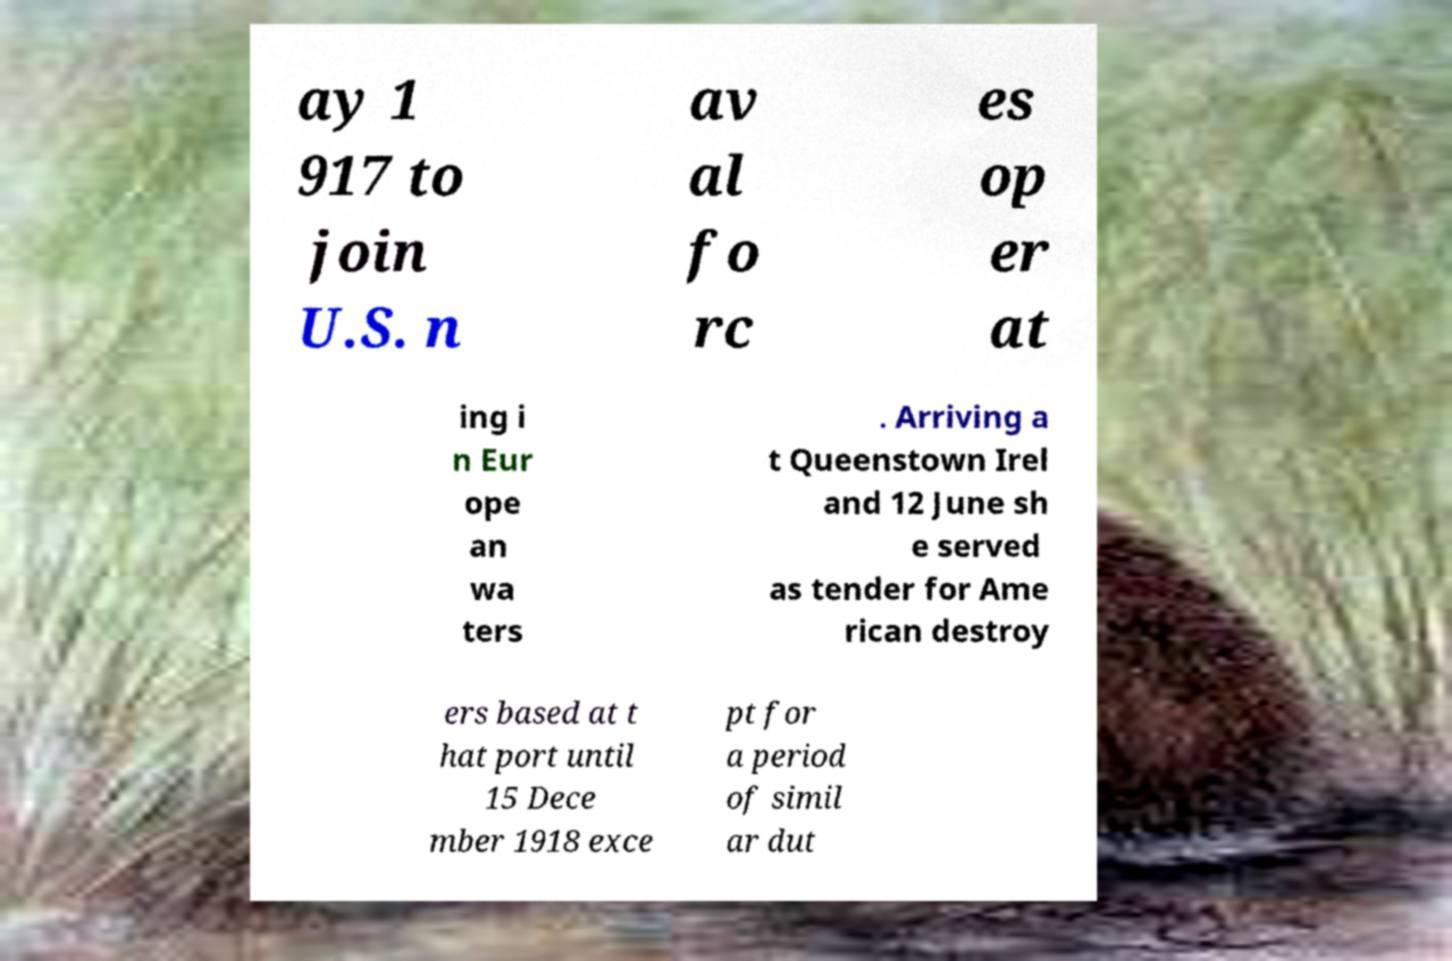Can you read and provide the text displayed in the image?This photo seems to have some interesting text. Can you extract and type it out for me? ay 1 917 to join U.S. n av al fo rc es op er at ing i n Eur ope an wa ters . Arriving a t Queenstown Irel and 12 June sh e served as tender for Ame rican destroy ers based at t hat port until 15 Dece mber 1918 exce pt for a period of simil ar dut 